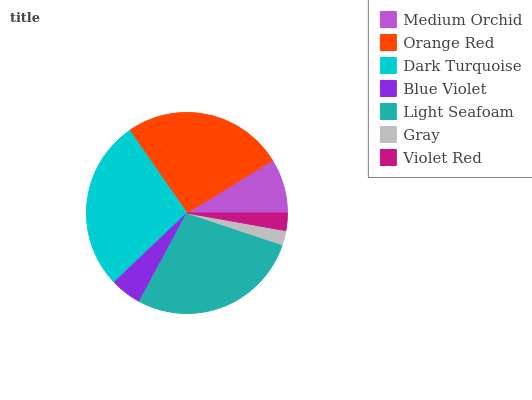Is Gray the minimum?
Answer yes or no. Yes. Is Light Seafoam the maximum?
Answer yes or no. Yes. Is Orange Red the minimum?
Answer yes or no. No. Is Orange Red the maximum?
Answer yes or no. No. Is Orange Red greater than Medium Orchid?
Answer yes or no. Yes. Is Medium Orchid less than Orange Red?
Answer yes or no. Yes. Is Medium Orchid greater than Orange Red?
Answer yes or no. No. Is Orange Red less than Medium Orchid?
Answer yes or no. No. Is Medium Orchid the high median?
Answer yes or no. Yes. Is Medium Orchid the low median?
Answer yes or no. Yes. Is Orange Red the high median?
Answer yes or no. No. Is Dark Turquoise the low median?
Answer yes or no. No. 